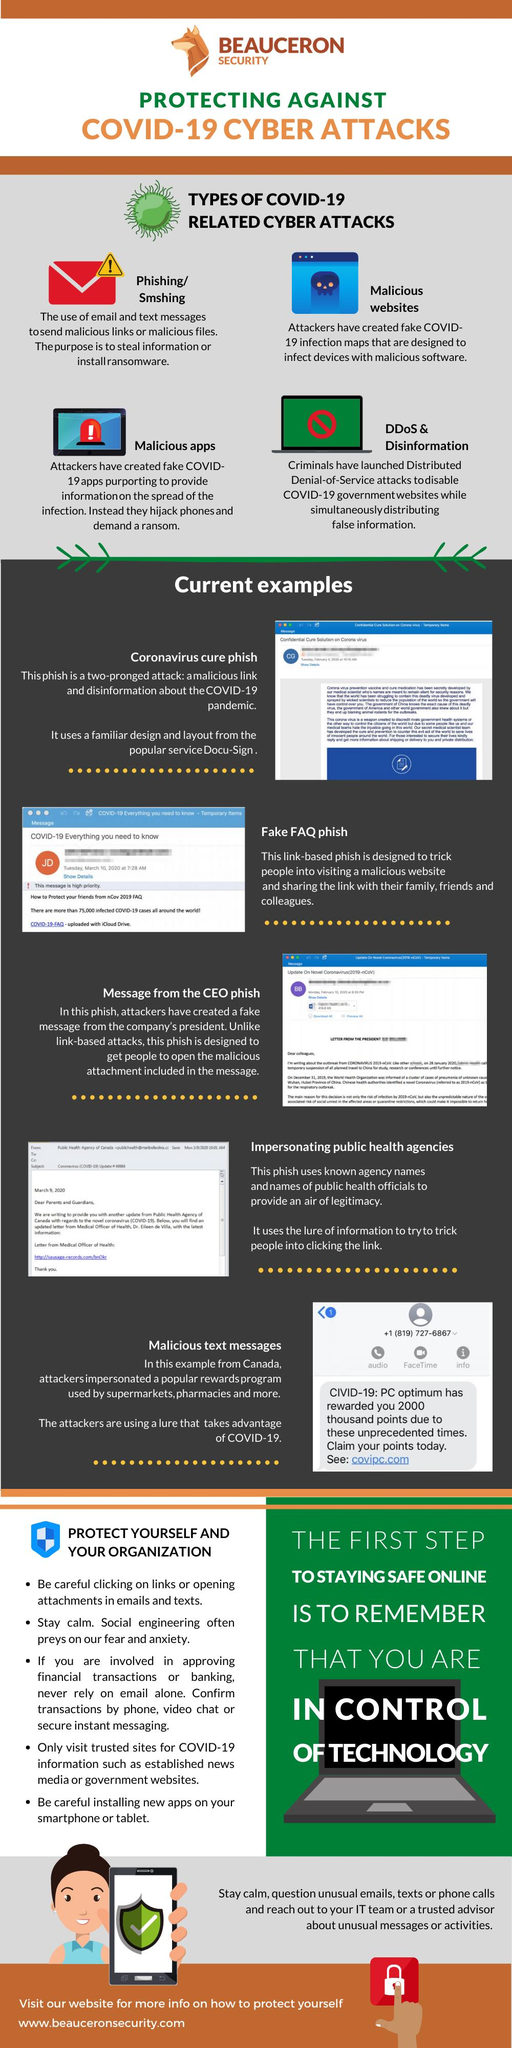Indicate a few pertinent items in this graphic. Malicious websites are a type of cyber attack in which fake maps are created in order to infect devices with malicious software. Fake apps created for the purpose of hijacking phones are considered malicious cyber attacks, which are included in the types of attacks mentioned. There are five bullet points under the section 'protect yourself and your organization.' It is mentioned that there are 5 examples of phishing in this text. Phishing and SMShing are types of cyber attacks that use email and text messages to send malicious links to trick victims into giving away sensitive information or installing malware on their devices. 